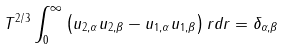Convert formula to latex. <formula><loc_0><loc_0><loc_500><loc_500>T ^ { 2 / 3 } \int _ { 0 } ^ { \infty } \left ( u _ { 2 , \alpha } u _ { 2 , \beta } - u _ { 1 , \alpha } u _ { 1 , \beta } \right ) r d r = \delta _ { \alpha , \beta }</formula> 